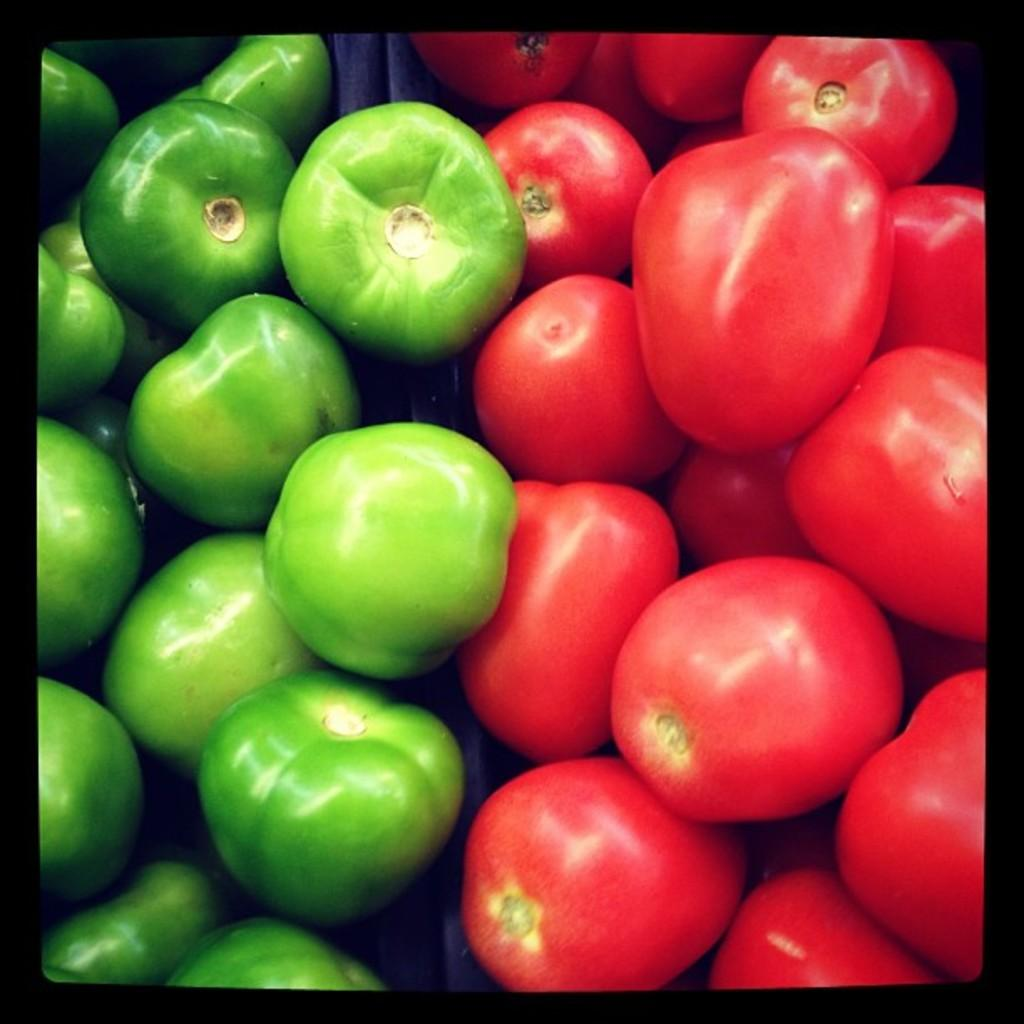What type of food is visible in the image? There are tomatoes in the image. Where is the team's nest located in the image? There is no team or nest present in the image; it features tomatoes. What type of road can be seen in the image? There is no road present in the image; it features tomatoes. 